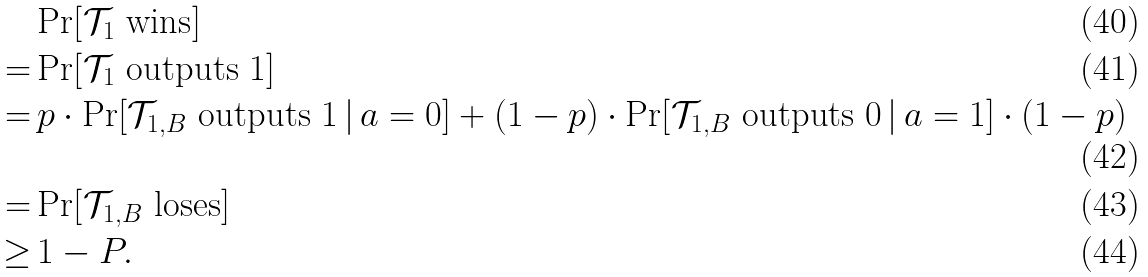Convert formula to latex. <formula><loc_0><loc_0><loc_500><loc_500>& \Pr [ \mathcal { T } _ { 1 } \text { wins} ] \\ = & \Pr [ \mathcal { T } _ { 1 } \text { outputs } 1 ] \\ = & \, p \cdot \Pr [ \mathcal { T } _ { 1 , B } \text { outputs } 1 \, | \, a = 0 ] + ( 1 - p ) \cdot \Pr [ \mathcal { T } _ { 1 , B } \text { outputs } 0 \, | \, a = 1 ] \cdot ( 1 - p ) \\ = & \Pr [ \mathcal { T } _ { 1 , B } \text { loses} ] \\ \geq & \, 1 - P .</formula> 